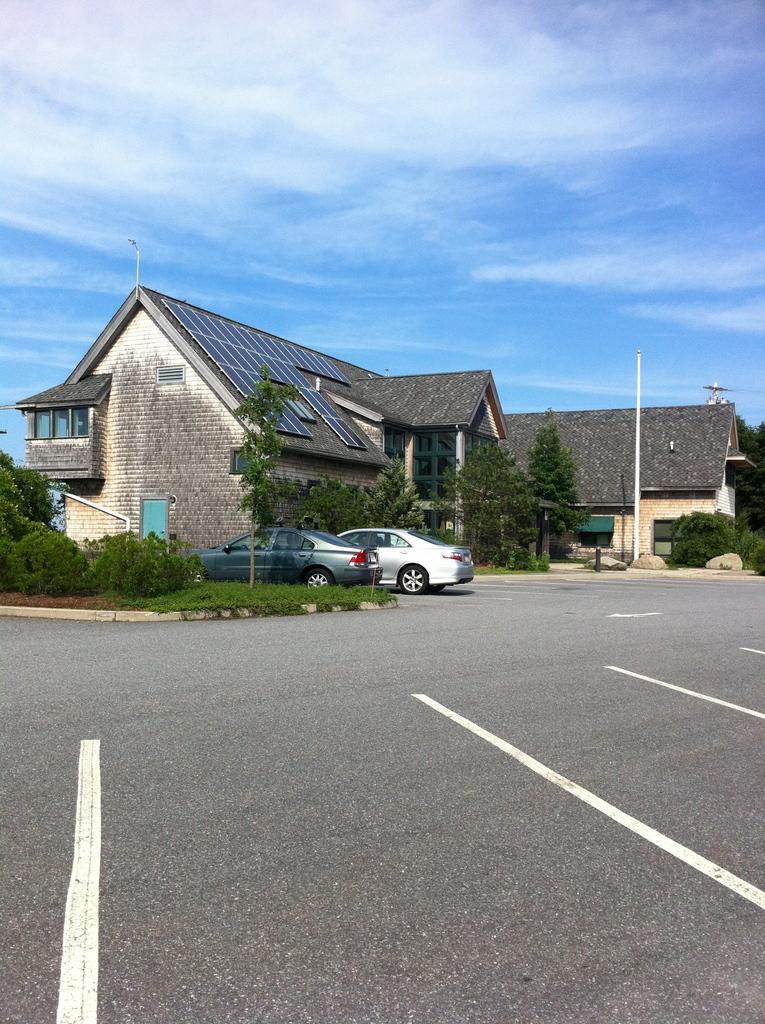Could you give a brief overview of what you see in this image? In this image I can see the road, 2 cars on the road, some grass, few trees and a pole which is white in color. In the background I can see a house which is cream, black and blue in color and the sky. 